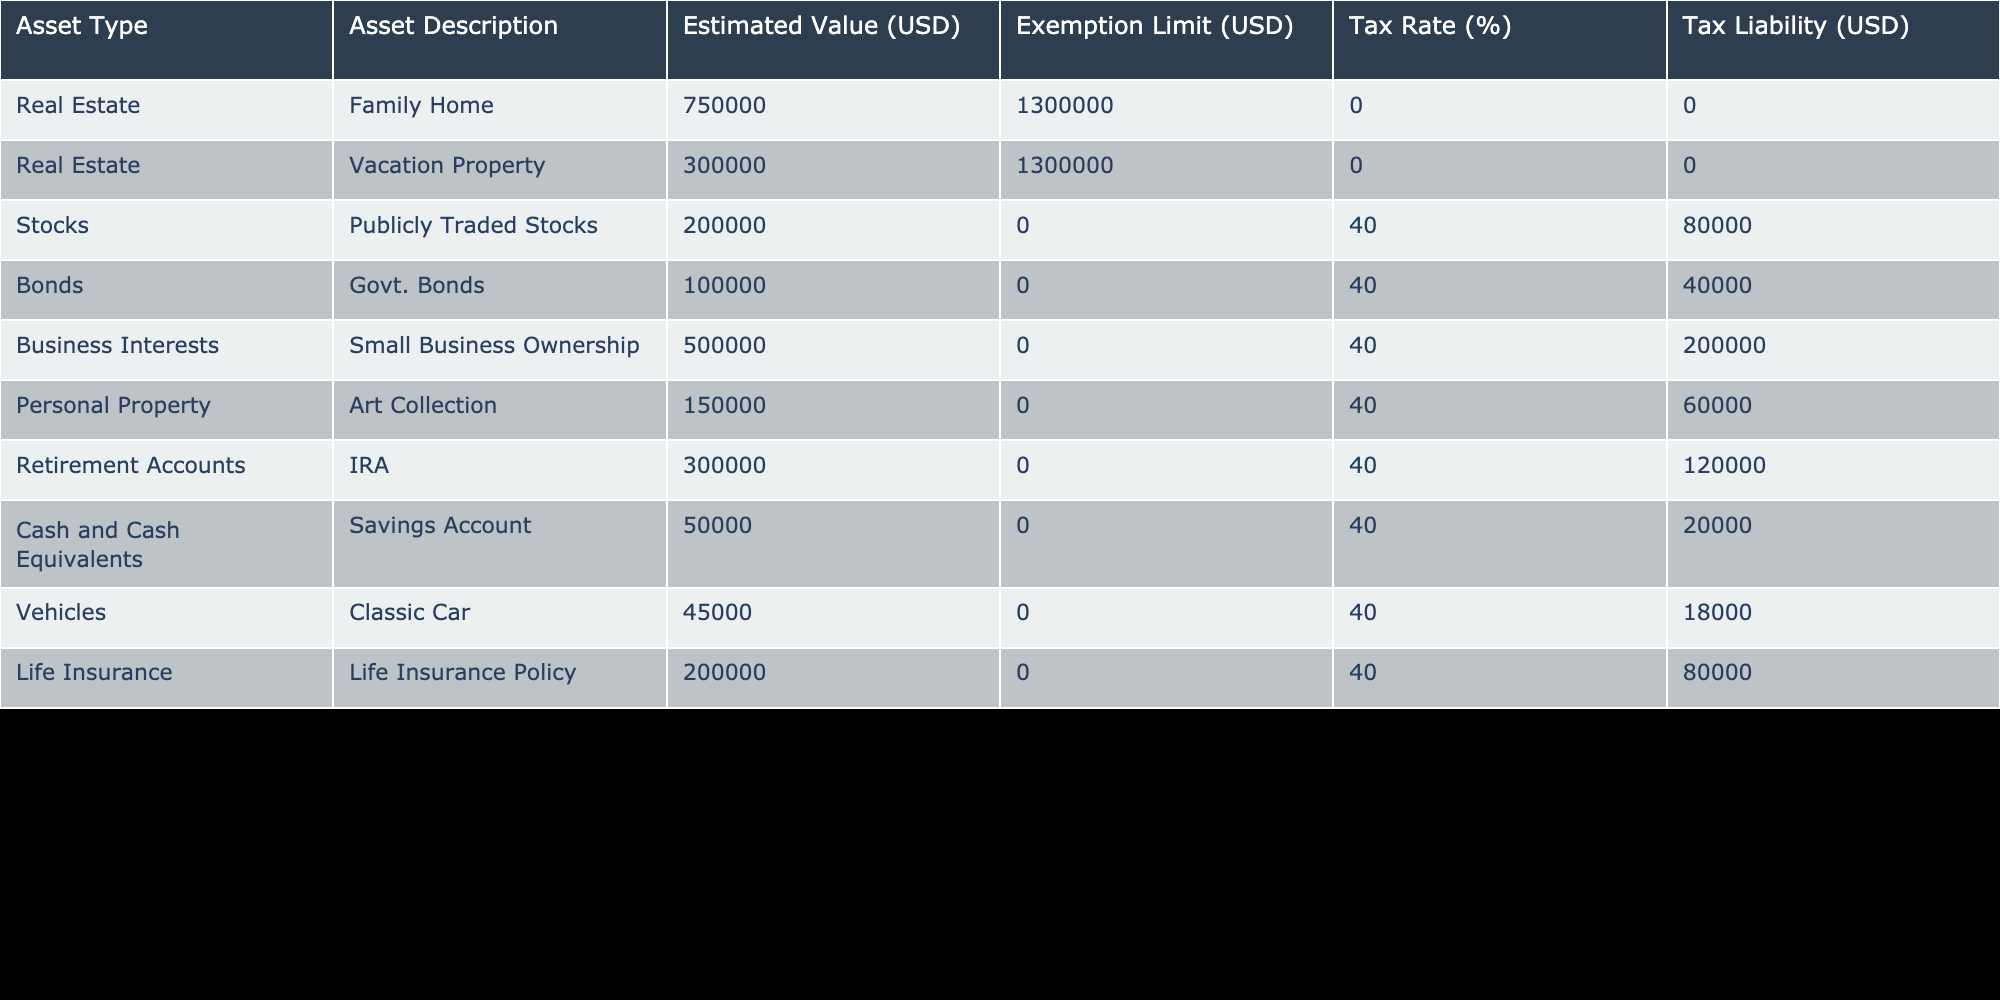What is the estimated value of the Family Home? The table lists the asset type as Real Estate and under Asset Description provides "Family Home," with an Estimated Value of 750000 USD.
Answer: 750000 USD What is the total tax liability for all stocks listed in the table? The only stock listed is "Publicly Traded Stocks" with a tax liability of 80000 USD. Therefore, the total tax liability for stocks is simply this value.
Answer: 80000 USD Does the vacation property incur any estate tax liabilities? The estimated value for the vacation property is 300000 USD, which is below the exemption limit of 1300000 USD, meaning it does not incur any estate tax liabilities.
Answer: Yes What is the combined estimated value of all personal properties listed in the table? The table lists one personal property, the "Art Collection," with an estimated value of 150000 USD. Since it's the only personal property present, the combined estimated value remains that amount.
Answer: 150000 USD Which asset has the highest tax liability, and what is that liability? To determine the asset with the highest tax liability, review the Tax Liability column. The "Business Interests" for "Small Business Ownership" has a tax liability of 200000 USD, which is the highest compared to any other entries.
Answer: Business Interests, 200000 USD What is the total estimated value of all real estate assets? The estimated values for real estate assets are the Family Home (750000 USD) and the Vacation Property (300000 USD). Summing these gives 750000 + 300000 = 1050000 USD as the total estimated value for real estate.
Answer: 1050000 USD Is the total tax liability greater than 300000 USD? To answer this, we sum up all tax liabilities from the table: 0 (Family Home) + 0 (Vacation Property) + 80000 (Publicly Traded Stocks) + 40000 (Govt. Bonds) + 200000 (Small Business Ownership) + 60000 (Art Collection) + 120000 (IRA) + 20000 (Savings Account) + 18000 (Classic Car) + 80000 (Life Insurance). The total comes to 400000 USD, which is indeed greater than 300000 USD.
Answer: Yes What is the average tax rate applied to the taxable assets in the table? The tax rates are applicable to the assets that have liability and are all at 40%, which is consistent across multiple asset types. Since every applicable asset (stocks, bonds, business interests, etc.) has the same tax rate, it can be concluded that the average tax rate is also 40%.
Answer: 40% What is the exemption limit for the IRA account? In the table, the exemption limit for the Retirement Accounts, specifically the IRA, is listed as 0 USD, indicating that there is no exemption limit applicable to this asset type.
Answer: 0 USD What is the total tax liability for cash and cash equivalents, including savings account? The "Savings Account" under cash and cash equivalents lists a tax liability of 20000 USD, which is the total since it's the only cash asset listed.
Answer: 20000 USD 